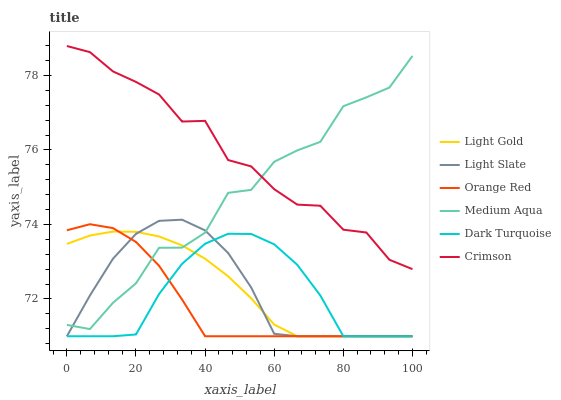Does Orange Red have the minimum area under the curve?
Answer yes or no. Yes. Does Crimson have the maximum area under the curve?
Answer yes or no. Yes. Does Dark Turquoise have the minimum area under the curve?
Answer yes or no. No. Does Dark Turquoise have the maximum area under the curve?
Answer yes or no. No. Is Light Gold the smoothest?
Answer yes or no. Yes. Is Medium Aqua the roughest?
Answer yes or no. Yes. Is Dark Turquoise the smoothest?
Answer yes or no. No. Is Dark Turquoise the roughest?
Answer yes or no. No. Does Medium Aqua have the lowest value?
Answer yes or no. No. Does Crimson have the highest value?
Answer yes or no. Yes. Does Medium Aqua have the highest value?
Answer yes or no. No. Is Light Slate less than Crimson?
Answer yes or no. Yes. Is Crimson greater than Orange Red?
Answer yes or no. Yes. Does Light Slate intersect Dark Turquoise?
Answer yes or no. Yes. Is Light Slate less than Dark Turquoise?
Answer yes or no. No. Is Light Slate greater than Dark Turquoise?
Answer yes or no. No. Does Light Slate intersect Crimson?
Answer yes or no. No. 